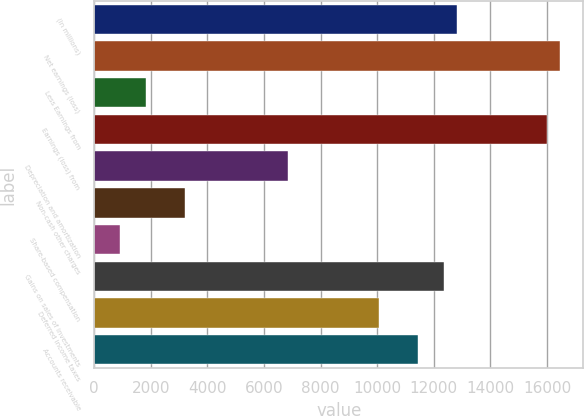<chart> <loc_0><loc_0><loc_500><loc_500><bar_chart><fcel>(In millions)<fcel>Net earnings (loss)<fcel>Less Earnings from<fcel>Earnings (loss) from<fcel>Depreciation and amortization<fcel>Non-cash other charges<fcel>Share-based compensation<fcel>Gains on sales of investments<fcel>Deferred income taxes<fcel>Accounts receivable<nl><fcel>12804<fcel>16460<fcel>1836<fcel>16003<fcel>6863<fcel>3207<fcel>922<fcel>12347<fcel>10062<fcel>11433<nl></chart> 